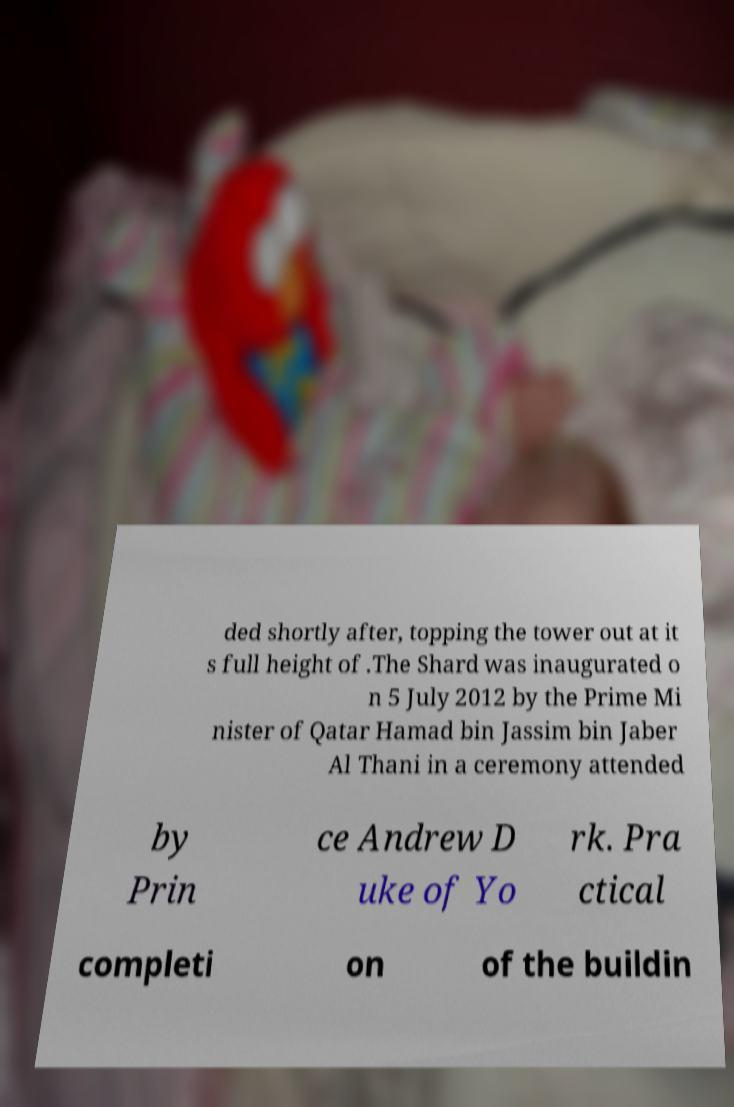Please identify and transcribe the text found in this image. ded shortly after, topping the tower out at it s full height of .The Shard was inaugurated o n 5 July 2012 by the Prime Mi nister of Qatar Hamad bin Jassim bin Jaber Al Thani in a ceremony attended by Prin ce Andrew D uke of Yo rk. Pra ctical completi on of the buildin 